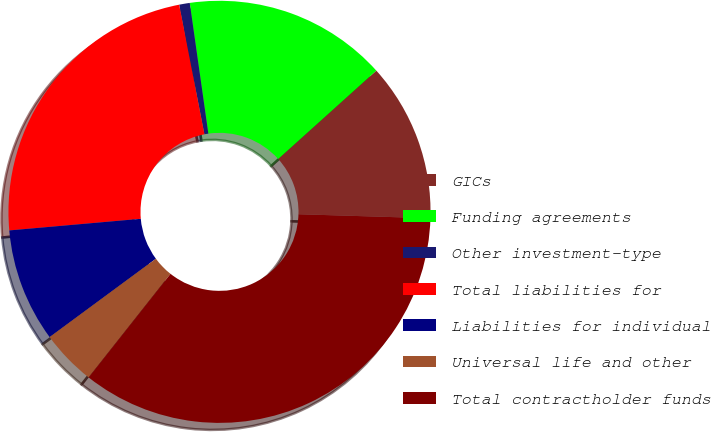<chart> <loc_0><loc_0><loc_500><loc_500><pie_chart><fcel>GICs<fcel>Funding agreements<fcel>Other investment-type<fcel>Total liabilities for<fcel>Liabilities for individual<fcel>Universal life and other<fcel>Total contractholder funds<nl><fcel>12.15%<fcel>15.58%<fcel>0.81%<fcel>23.34%<fcel>8.71%<fcel>4.24%<fcel>35.16%<nl></chart> 